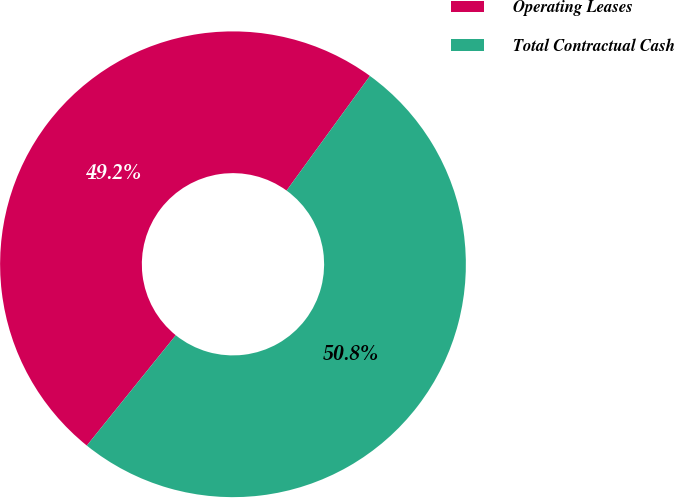Convert chart to OTSL. <chart><loc_0><loc_0><loc_500><loc_500><pie_chart><fcel>Operating Leases<fcel>Total Contractual Cash<nl><fcel>49.21%<fcel>50.79%<nl></chart> 